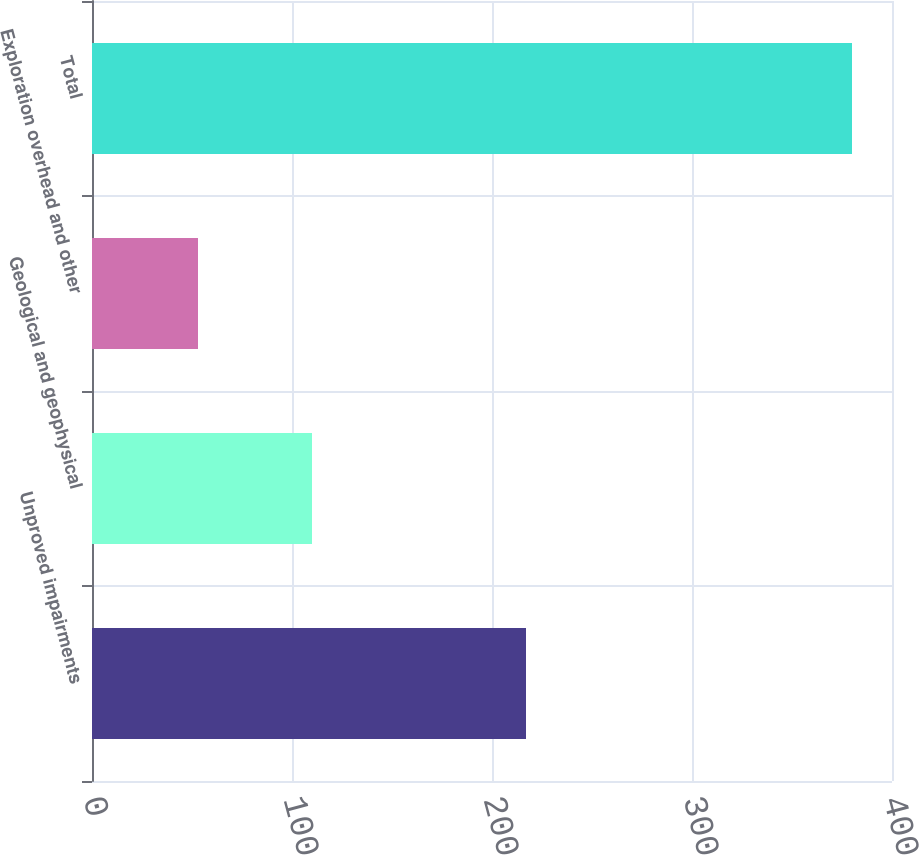Convert chart. <chart><loc_0><loc_0><loc_500><loc_500><bar_chart><fcel>Unproved impairments<fcel>Geological and geophysical<fcel>Exploration overhead and other<fcel>Total<nl><fcel>217<fcel>110<fcel>53<fcel>380<nl></chart> 